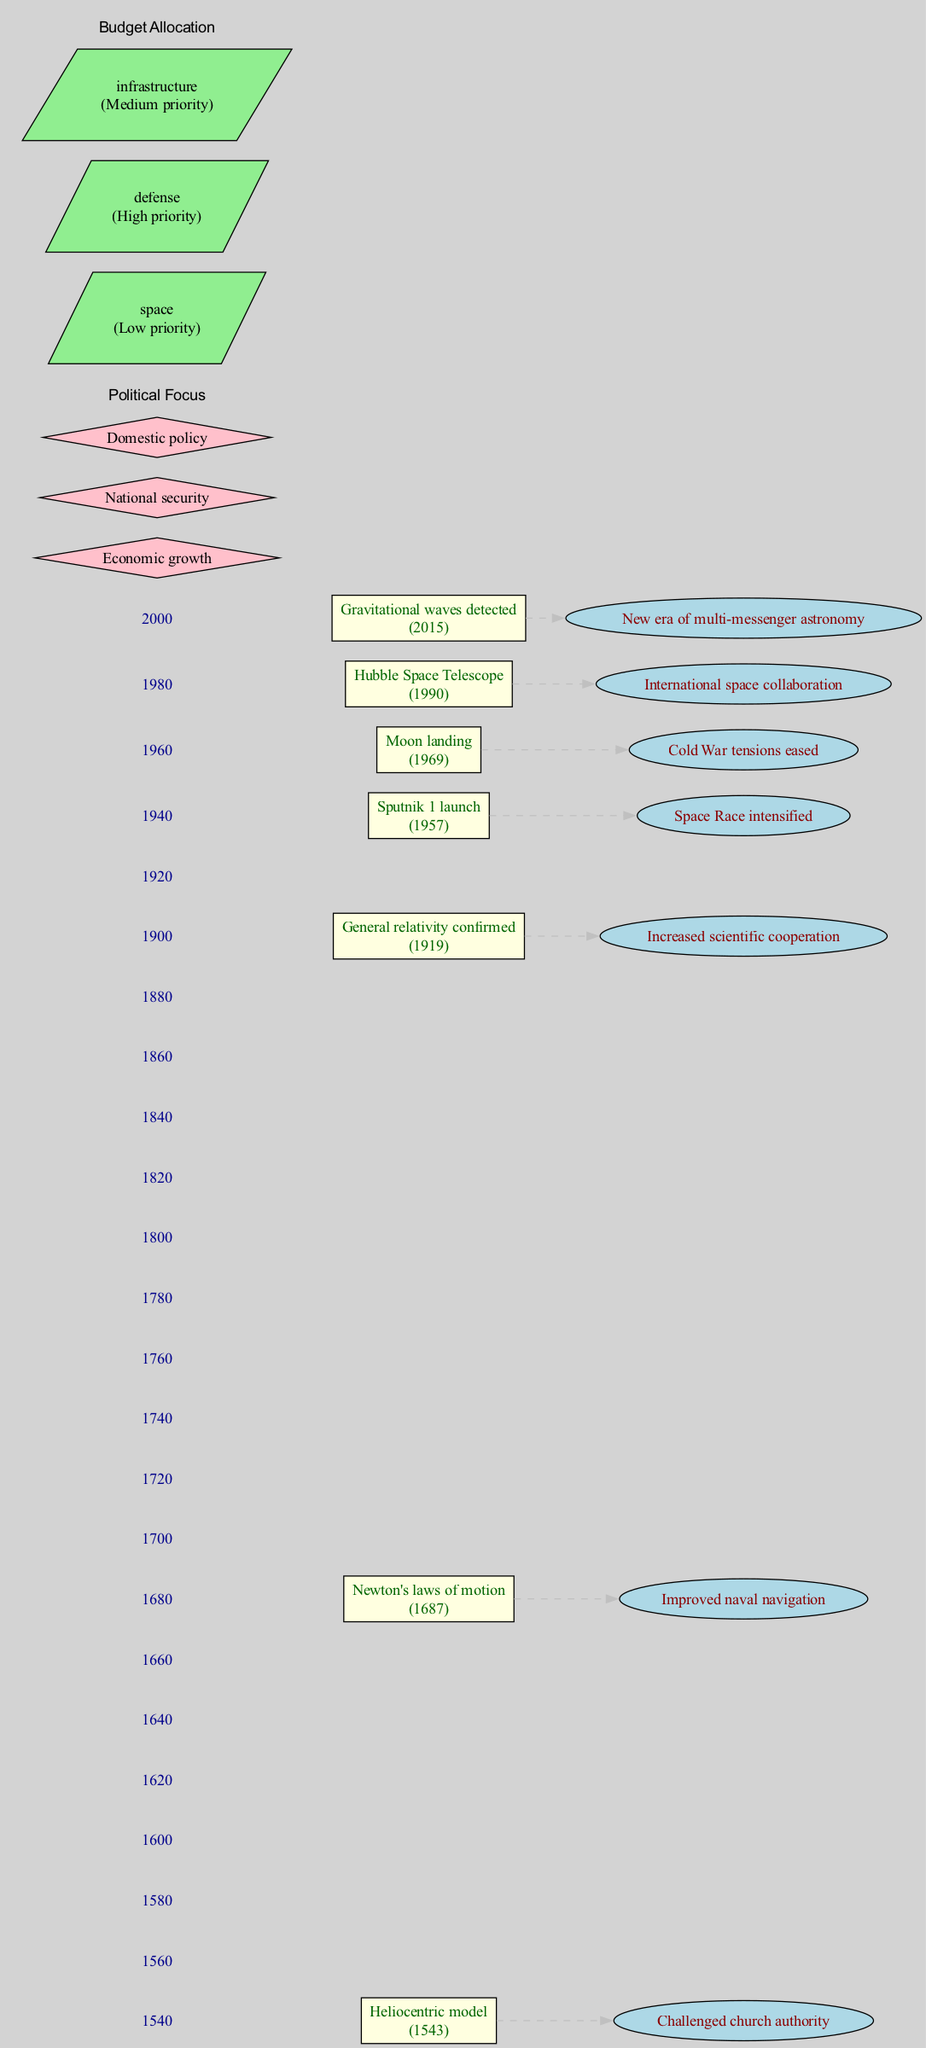What's the first major astronomical discovery? The diagram indicates the first major discovery is the "Heliocentric model" made in the year 1543.
Answer: Heliocentric model What year did the Moon landing occur? By examining the timeline in the diagram, the Moon landing occurred in the year 1969.
Answer: 1969 How many major discoveries are shown in the diagram? The timeline presents a total of seven key discoveries listed in chronological order.
Answer: Seven What impact did the confirmation of general relativity have? The diagram links the confirmation of general relativity in 1919 with the impact of "Increased scientific cooperation."
Answer: Increased scientific cooperation Which discovery occurred during the Space Race? The launch of Sputnik 1 in 1957 is noted in the diagram as occurring during the Space Race, indicating its significance in that context.
Answer: Sputnik 1 launch What is the budget priority for space according to the diagram? The budget allocation section of the diagram specifies that the priority for the space program is categorized as "Low priority."
Answer: Low priority Which political focus relates to international space collaboration? The diagram connects the Hubble Space Telescope launched in 1990 to the impact of "International space collaboration," indicating this political focus is relevant to that discovery.
Answer: International space collaboration What is the last major discovery listed in the timeline? The final entry in the timeline indicates that the last major astronomical discovery is the "Gravitational waves detected" in 2015.
Answer: Gravitational waves detected Which discovery is associated with easing Cold War tensions? According to the diagram, the Moon landing in 1969 is connected to the impact of "Cold War tensions eased," highlighting its role in that political context.
Answer: Moon landing 